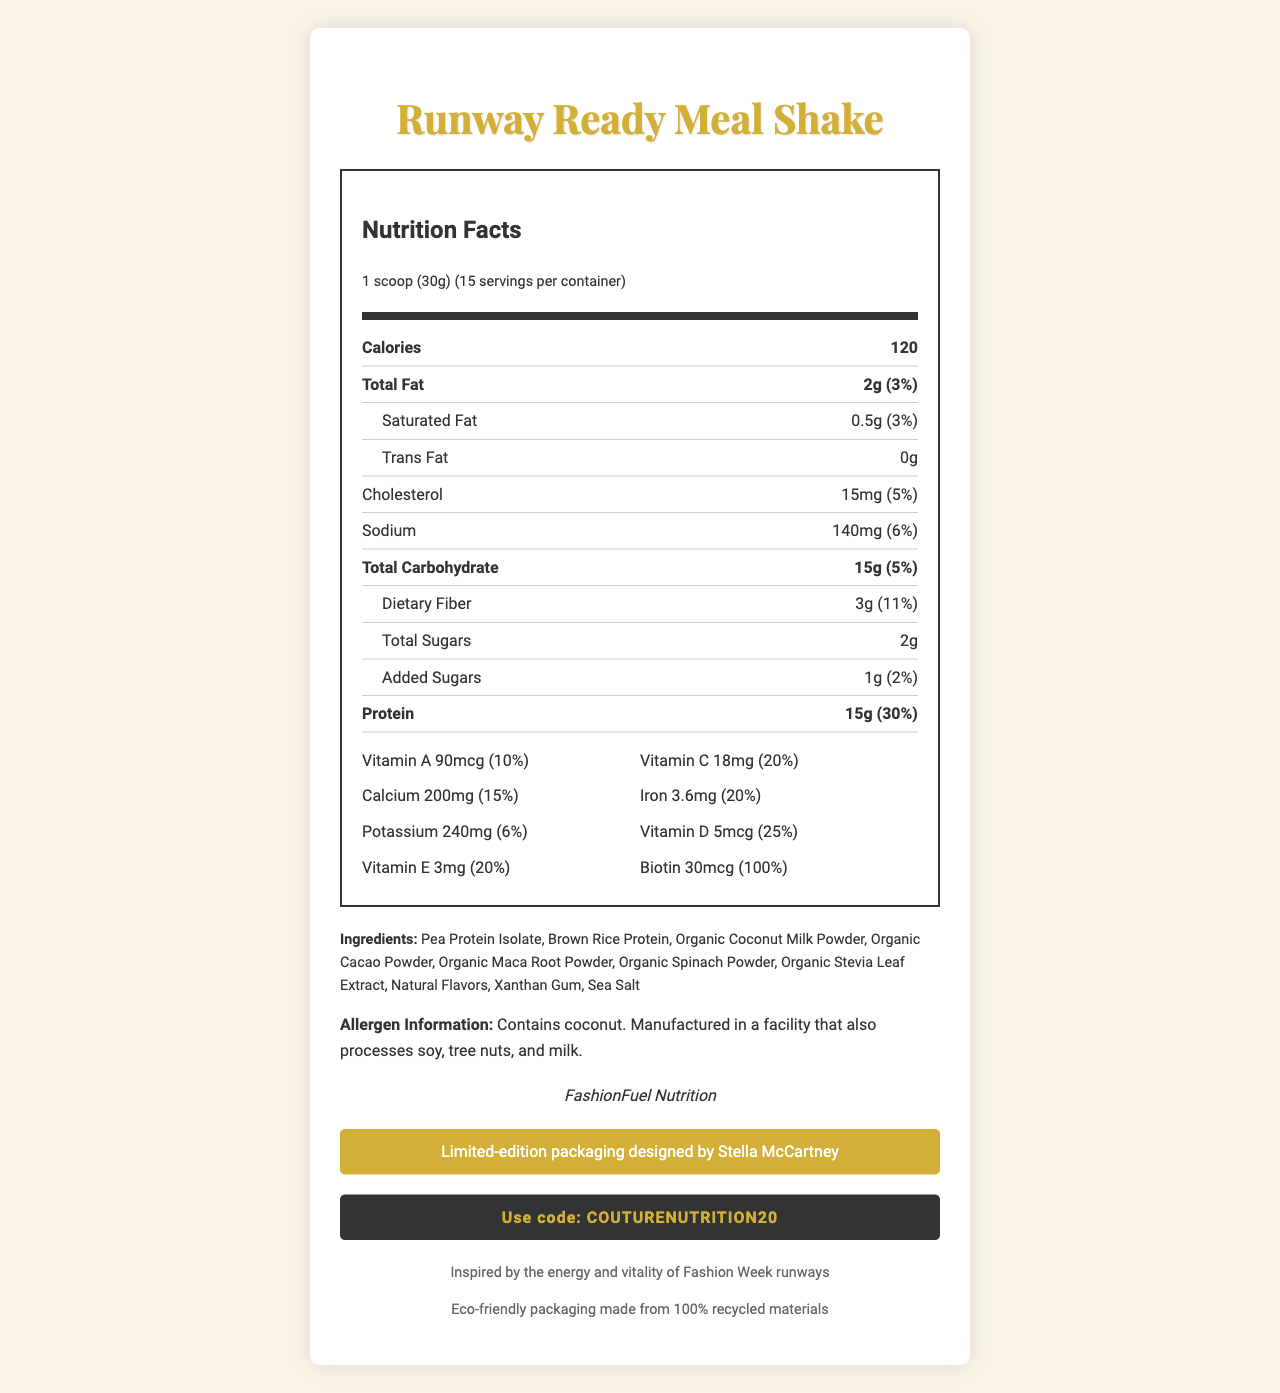what is the serving size? The serving size is explicitly mentioned in the document as "1 scoop (30g)".
Answer: 1 scoop (30g) how many calories are in one serving? The document states that each serving contains 120 calories.
Answer: 120 calories what is the amount of protein per serving? The document lists the amount of protein per serving as 15g.
Answer: 15g what are the ingredients of the meal shake? The ingredients are all listed under the ingredients section.
Answer: Pea Protein Isolate, Brown Rice Protein, Organic Coconut Milk Powder, Organic Cacao Powder, Organic Maca Root Powder, Organic Spinach Powder, Organic Stevia Leaf Extract, Natural Flavors, Xanthan Gum, Sea Salt does the product contain any allergens? The document mentions that the product contains coconut and is manufactured in a facility that also processes soy, tree nuts, and milk.
Answer: Yes which brand makes the "Runway Ready Meal Shake"? A. FashionFuel Nutrition B. HealthBoost C. Fashion Energy The document states that "FashionFuel Nutrition" is the brand that makes the product.
Answer: A. FashionFuel Nutrition how much dietary fiber is in each serving? The document lists the amount of dietary fiber per serving as 3g.
Answer: 3g what is the vitamin A content in one serving? A. 90mcg B. 5mcg C. 240mg The document lists the amount of vitamin A per serving as 90mcg.
Answer: A. 90mcg does the product have any added sugars? The document indicates there are added sugars with an amount listed as 1g per serving.
Answer: Yes what is the main idea of the document? The document gives comprehensive information about the "Runway Ready Meal Shake," including nutritional facts, ingredients, allergen information, brand and packaging details, and a discount code.
Answer: The document provides detailed nutritional information for a limited-edition "Runway Ready Meal Shake" by FashionFuel Nutrition, its ingredients, allergen information, and exclusive packaging designed by Stella McCartney. how many servings are in one container? The document mentions that there are 15 servings per container.
Answer: 15 is the product vegan-friendly? The document does not explicitly state whether the product is vegan-friendly, although the listed ingredients do not contain obvious animal products except for possible cross-contamination.
Answer: Not enough information does the meal shake include any eco-friendly claims? The document mentions that the packaging is made from 100% recycled materials and claims it is eco-friendly.
Answer: Yes 